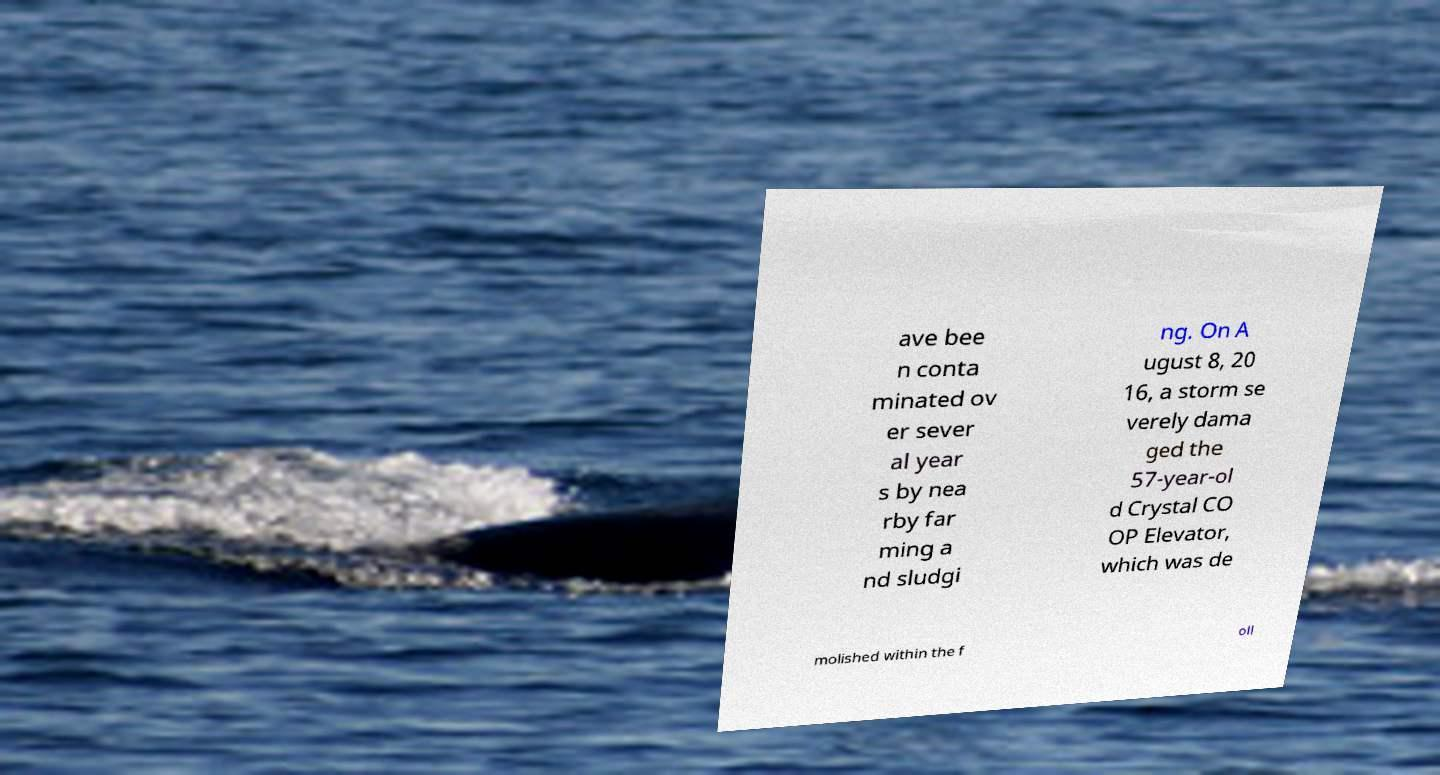Can you read and provide the text displayed in the image?This photo seems to have some interesting text. Can you extract and type it out for me? ave bee n conta minated ov er sever al year s by nea rby far ming a nd sludgi ng. On A ugust 8, 20 16, a storm se verely dama ged the 57-year-ol d Crystal CO OP Elevator, which was de molished within the f oll 